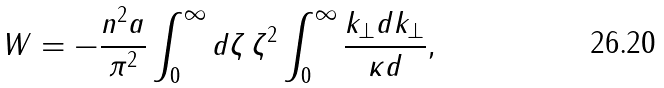Convert formula to latex. <formula><loc_0><loc_0><loc_500><loc_500>W = - \frac { n ^ { 2 } a } { \pi ^ { 2 } } \int _ { 0 } ^ { \infty } d \zeta \, \zeta ^ { 2 } \int _ { 0 } ^ { \infty } \frac { k _ { \perp } d k _ { \perp } } { \kappa d } ,</formula> 